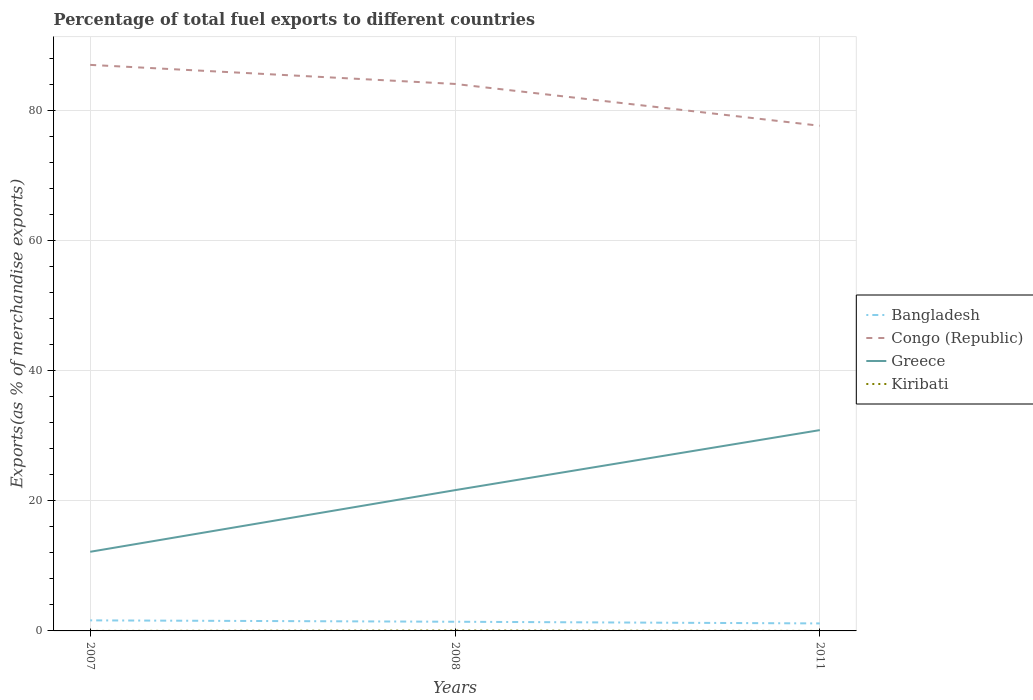How many different coloured lines are there?
Your answer should be compact. 4. Across all years, what is the maximum percentage of exports to different countries in Kiribati?
Offer a very short reply. 0. What is the total percentage of exports to different countries in Congo (Republic) in the graph?
Provide a succinct answer. 9.36. What is the difference between the highest and the second highest percentage of exports to different countries in Bangladesh?
Your answer should be compact. 0.47. Is the percentage of exports to different countries in Bangladesh strictly greater than the percentage of exports to different countries in Kiribati over the years?
Your response must be concise. No. How many years are there in the graph?
Your response must be concise. 3. Are the values on the major ticks of Y-axis written in scientific E-notation?
Your answer should be compact. No. Does the graph contain any zero values?
Your answer should be compact. No. Does the graph contain grids?
Offer a very short reply. Yes. Where does the legend appear in the graph?
Offer a terse response. Center right. What is the title of the graph?
Your response must be concise. Percentage of total fuel exports to different countries. What is the label or title of the X-axis?
Give a very brief answer. Years. What is the label or title of the Y-axis?
Offer a very short reply. Exports(as % of merchandise exports). What is the Exports(as % of merchandise exports) of Bangladesh in 2007?
Offer a terse response. 1.62. What is the Exports(as % of merchandise exports) in Congo (Republic) in 2007?
Your response must be concise. 87.02. What is the Exports(as % of merchandise exports) in Greece in 2007?
Offer a terse response. 12.17. What is the Exports(as % of merchandise exports) of Kiribati in 2007?
Your answer should be very brief. 0. What is the Exports(as % of merchandise exports) of Bangladesh in 2008?
Give a very brief answer. 1.41. What is the Exports(as % of merchandise exports) of Congo (Republic) in 2008?
Keep it short and to the point. 84.09. What is the Exports(as % of merchandise exports) in Greece in 2008?
Keep it short and to the point. 21.64. What is the Exports(as % of merchandise exports) of Kiribati in 2008?
Ensure brevity in your answer.  0.06. What is the Exports(as % of merchandise exports) of Bangladesh in 2011?
Provide a succinct answer. 1.15. What is the Exports(as % of merchandise exports) in Congo (Republic) in 2011?
Offer a very short reply. 77.67. What is the Exports(as % of merchandise exports) in Greece in 2011?
Make the answer very short. 30.87. What is the Exports(as % of merchandise exports) in Kiribati in 2011?
Ensure brevity in your answer.  0. Across all years, what is the maximum Exports(as % of merchandise exports) of Bangladesh?
Provide a short and direct response. 1.62. Across all years, what is the maximum Exports(as % of merchandise exports) in Congo (Republic)?
Your response must be concise. 87.02. Across all years, what is the maximum Exports(as % of merchandise exports) in Greece?
Make the answer very short. 30.87. Across all years, what is the maximum Exports(as % of merchandise exports) of Kiribati?
Provide a short and direct response. 0.06. Across all years, what is the minimum Exports(as % of merchandise exports) in Bangladesh?
Give a very brief answer. 1.15. Across all years, what is the minimum Exports(as % of merchandise exports) of Congo (Republic)?
Ensure brevity in your answer.  77.67. Across all years, what is the minimum Exports(as % of merchandise exports) of Greece?
Provide a short and direct response. 12.17. Across all years, what is the minimum Exports(as % of merchandise exports) of Kiribati?
Give a very brief answer. 0. What is the total Exports(as % of merchandise exports) in Bangladesh in the graph?
Offer a terse response. 4.19. What is the total Exports(as % of merchandise exports) of Congo (Republic) in the graph?
Offer a terse response. 248.79. What is the total Exports(as % of merchandise exports) of Greece in the graph?
Provide a short and direct response. 64.68. What is the total Exports(as % of merchandise exports) of Kiribati in the graph?
Give a very brief answer. 0.06. What is the difference between the Exports(as % of merchandise exports) of Bangladesh in 2007 and that in 2008?
Provide a short and direct response. 0.21. What is the difference between the Exports(as % of merchandise exports) in Congo (Republic) in 2007 and that in 2008?
Ensure brevity in your answer.  2.93. What is the difference between the Exports(as % of merchandise exports) of Greece in 2007 and that in 2008?
Provide a short and direct response. -9.47. What is the difference between the Exports(as % of merchandise exports) in Kiribati in 2007 and that in 2008?
Your response must be concise. -0.06. What is the difference between the Exports(as % of merchandise exports) in Bangladesh in 2007 and that in 2011?
Keep it short and to the point. 0.47. What is the difference between the Exports(as % of merchandise exports) in Congo (Republic) in 2007 and that in 2011?
Your response must be concise. 9.36. What is the difference between the Exports(as % of merchandise exports) of Greece in 2007 and that in 2011?
Make the answer very short. -18.71. What is the difference between the Exports(as % of merchandise exports) in Kiribati in 2007 and that in 2011?
Give a very brief answer. 0. What is the difference between the Exports(as % of merchandise exports) in Bangladesh in 2008 and that in 2011?
Your response must be concise. 0.26. What is the difference between the Exports(as % of merchandise exports) in Congo (Republic) in 2008 and that in 2011?
Your answer should be compact. 6.43. What is the difference between the Exports(as % of merchandise exports) in Greece in 2008 and that in 2011?
Make the answer very short. -9.23. What is the difference between the Exports(as % of merchandise exports) of Kiribati in 2008 and that in 2011?
Keep it short and to the point. 0.06. What is the difference between the Exports(as % of merchandise exports) of Bangladesh in 2007 and the Exports(as % of merchandise exports) of Congo (Republic) in 2008?
Keep it short and to the point. -82.47. What is the difference between the Exports(as % of merchandise exports) in Bangladesh in 2007 and the Exports(as % of merchandise exports) in Greece in 2008?
Offer a terse response. -20.02. What is the difference between the Exports(as % of merchandise exports) of Bangladesh in 2007 and the Exports(as % of merchandise exports) of Kiribati in 2008?
Provide a succinct answer. 1.56. What is the difference between the Exports(as % of merchandise exports) in Congo (Republic) in 2007 and the Exports(as % of merchandise exports) in Greece in 2008?
Ensure brevity in your answer.  65.38. What is the difference between the Exports(as % of merchandise exports) in Congo (Republic) in 2007 and the Exports(as % of merchandise exports) in Kiribati in 2008?
Keep it short and to the point. 86.96. What is the difference between the Exports(as % of merchandise exports) in Greece in 2007 and the Exports(as % of merchandise exports) in Kiribati in 2008?
Provide a succinct answer. 12.1. What is the difference between the Exports(as % of merchandise exports) in Bangladesh in 2007 and the Exports(as % of merchandise exports) in Congo (Republic) in 2011?
Make the answer very short. -76.04. What is the difference between the Exports(as % of merchandise exports) in Bangladesh in 2007 and the Exports(as % of merchandise exports) in Greece in 2011?
Your response must be concise. -29.25. What is the difference between the Exports(as % of merchandise exports) in Bangladesh in 2007 and the Exports(as % of merchandise exports) in Kiribati in 2011?
Keep it short and to the point. 1.62. What is the difference between the Exports(as % of merchandise exports) in Congo (Republic) in 2007 and the Exports(as % of merchandise exports) in Greece in 2011?
Your response must be concise. 56.15. What is the difference between the Exports(as % of merchandise exports) in Congo (Republic) in 2007 and the Exports(as % of merchandise exports) in Kiribati in 2011?
Give a very brief answer. 87.02. What is the difference between the Exports(as % of merchandise exports) in Greece in 2007 and the Exports(as % of merchandise exports) in Kiribati in 2011?
Make the answer very short. 12.17. What is the difference between the Exports(as % of merchandise exports) of Bangladesh in 2008 and the Exports(as % of merchandise exports) of Congo (Republic) in 2011?
Your answer should be very brief. -76.26. What is the difference between the Exports(as % of merchandise exports) in Bangladesh in 2008 and the Exports(as % of merchandise exports) in Greece in 2011?
Give a very brief answer. -29.46. What is the difference between the Exports(as % of merchandise exports) in Bangladesh in 2008 and the Exports(as % of merchandise exports) in Kiribati in 2011?
Provide a short and direct response. 1.41. What is the difference between the Exports(as % of merchandise exports) in Congo (Republic) in 2008 and the Exports(as % of merchandise exports) in Greece in 2011?
Provide a short and direct response. 53.22. What is the difference between the Exports(as % of merchandise exports) of Congo (Republic) in 2008 and the Exports(as % of merchandise exports) of Kiribati in 2011?
Provide a short and direct response. 84.09. What is the difference between the Exports(as % of merchandise exports) of Greece in 2008 and the Exports(as % of merchandise exports) of Kiribati in 2011?
Your answer should be very brief. 21.64. What is the average Exports(as % of merchandise exports) in Bangladesh per year?
Offer a very short reply. 1.4. What is the average Exports(as % of merchandise exports) in Congo (Republic) per year?
Provide a succinct answer. 82.93. What is the average Exports(as % of merchandise exports) of Greece per year?
Provide a short and direct response. 21.56. What is the average Exports(as % of merchandise exports) of Kiribati per year?
Make the answer very short. 0.02. In the year 2007, what is the difference between the Exports(as % of merchandise exports) in Bangladesh and Exports(as % of merchandise exports) in Congo (Republic)?
Provide a succinct answer. -85.4. In the year 2007, what is the difference between the Exports(as % of merchandise exports) of Bangladesh and Exports(as % of merchandise exports) of Greece?
Provide a succinct answer. -10.54. In the year 2007, what is the difference between the Exports(as % of merchandise exports) in Bangladesh and Exports(as % of merchandise exports) in Kiribati?
Provide a short and direct response. 1.62. In the year 2007, what is the difference between the Exports(as % of merchandise exports) of Congo (Republic) and Exports(as % of merchandise exports) of Greece?
Your answer should be compact. 74.86. In the year 2007, what is the difference between the Exports(as % of merchandise exports) in Congo (Republic) and Exports(as % of merchandise exports) in Kiribati?
Your answer should be very brief. 87.02. In the year 2007, what is the difference between the Exports(as % of merchandise exports) in Greece and Exports(as % of merchandise exports) in Kiribati?
Give a very brief answer. 12.17. In the year 2008, what is the difference between the Exports(as % of merchandise exports) in Bangladesh and Exports(as % of merchandise exports) in Congo (Republic)?
Your response must be concise. -82.68. In the year 2008, what is the difference between the Exports(as % of merchandise exports) in Bangladesh and Exports(as % of merchandise exports) in Greece?
Your answer should be very brief. -20.23. In the year 2008, what is the difference between the Exports(as % of merchandise exports) of Bangladesh and Exports(as % of merchandise exports) of Kiribati?
Give a very brief answer. 1.35. In the year 2008, what is the difference between the Exports(as % of merchandise exports) in Congo (Republic) and Exports(as % of merchandise exports) in Greece?
Your answer should be very brief. 62.45. In the year 2008, what is the difference between the Exports(as % of merchandise exports) in Congo (Republic) and Exports(as % of merchandise exports) in Kiribati?
Provide a short and direct response. 84.03. In the year 2008, what is the difference between the Exports(as % of merchandise exports) in Greece and Exports(as % of merchandise exports) in Kiribati?
Provide a short and direct response. 21.58. In the year 2011, what is the difference between the Exports(as % of merchandise exports) in Bangladesh and Exports(as % of merchandise exports) in Congo (Republic)?
Make the answer very short. -76.51. In the year 2011, what is the difference between the Exports(as % of merchandise exports) of Bangladesh and Exports(as % of merchandise exports) of Greece?
Your answer should be very brief. -29.72. In the year 2011, what is the difference between the Exports(as % of merchandise exports) of Bangladesh and Exports(as % of merchandise exports) of Kiribati?
Offer a terse response. 1.15. In the year 2011, what is the difference between the Exports(as % of merchandise exports) in Congo (Republic) and Exports(as % of merchandise exports) in Greece?
Provide a succinct answer. 46.79. In the year 2011, what is the difference between the Exports(as % of merchandise exports) of Congo (Republic) and Exports(as % of merchandise exports) of Kiribati?
Give a very brief answer. 77.67. In the year 2011, what is the difference between the Exports(as % of merchandise exports) of Greece and Exports(as % of merchandise exports) of Kiribati?
Your answer should be very brief. 30.87. What is the ratio of the Exports(as % of merchandise exports) in Bangladesh in 2007 to that in 2008?
Your answer should be very brief. 1.15. What is the ratio of the Exports(as % of merchandise exports) of Congo (Republic) in 2007 to that in 2008?
Provide a succinct answer. 1.03. What is the ratio of the Exports(as % of merchandise exports) in Greece in 2007 to that in 2008?
Ensure brevity in your answer.  0.56. What is the ratio of the Exports(as % of merchandise exports) of Kiribati in 2007 to that in 2008?
Your answer should be very brief. 0. What is the ratio of the Exports(as % of merchandise exports) in Bangladesh in 2007 to that in 2011?
Provide a succinct answer. 1.41. What is the ratio of the Exports(as % of merchandise exports) of Congo (Republic) in 2007 to that in 2011?
Your answer should be very brief. 1.12. What is the ratio of the Exports(as % of merchandise exports) in Greece in 2007 to that in 2011?
Offer a very short reply. 0.39. What is the ratio of the Exports(as % of merchandise exports) of Kiribati in 2007 to that in 2011?
Your answer should be very brief. 2.12. What is the ratio of the Exports(as % of merchandise exports) of Bangladesh in 2008 to that in 2011?
Provide a short and direct response. 1.22. What is the ratio of the Exports(as % of merchandise exports) in Congo (Republic) in 2008 to that in 2011?
Your response must be concise. 1.08. What is the ratio of the Exports(as % of merchandise exports) of Greece in 2008 to that in 2011?
Provide a succinct answer. 0.7. What is the ratio of the Exports(as % of merchandise exports) in Kiribati in 2008 to that in 2011?
Offer a terse response. 540.83. What is the difference between the highest and the second highest Exports(as % of merchandise exports) of Bangladesh?
Give a very brief answer. 0.21. What is the difference between the highest and the second highest Exports(as % of merchandise exports) in Congo (Republic)?
Ensure brevity in your answer.  2.93. What is the difference between the highest and the second highest Exports(as % of merchandise exports) of Greece?
Your answer should be very brief. 9.23. What is the difference between the highest and the second highest Exports(as % of merchandise exports) in Kiribati?
Make the answer very short. 0.06. What is the difference between the highest and the lowest Exports(as % of merchandise exports) in Bangladesh?
Give a very brief answer. 0.47. What is the difference between the highest and the lowest Exports(as % of merchandise exports) of Congo (Republic)?
Provide a succinct answer. 9.36. What is the difference between the highest and the lowest Exports(as % of merchandise exports) of Greece?
Offer a very short reply. 18.71. What is the difference between the highest and the lowest Exports(as % of merchandise exports) of Kiribati?
Your response must be concise. 0.06. 